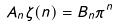<formula> <loc_0><loc_0><loc_500><loc_500>A _ { n } \zeta ( n ) = B _ { n } \pi ^ { n }</formula> 